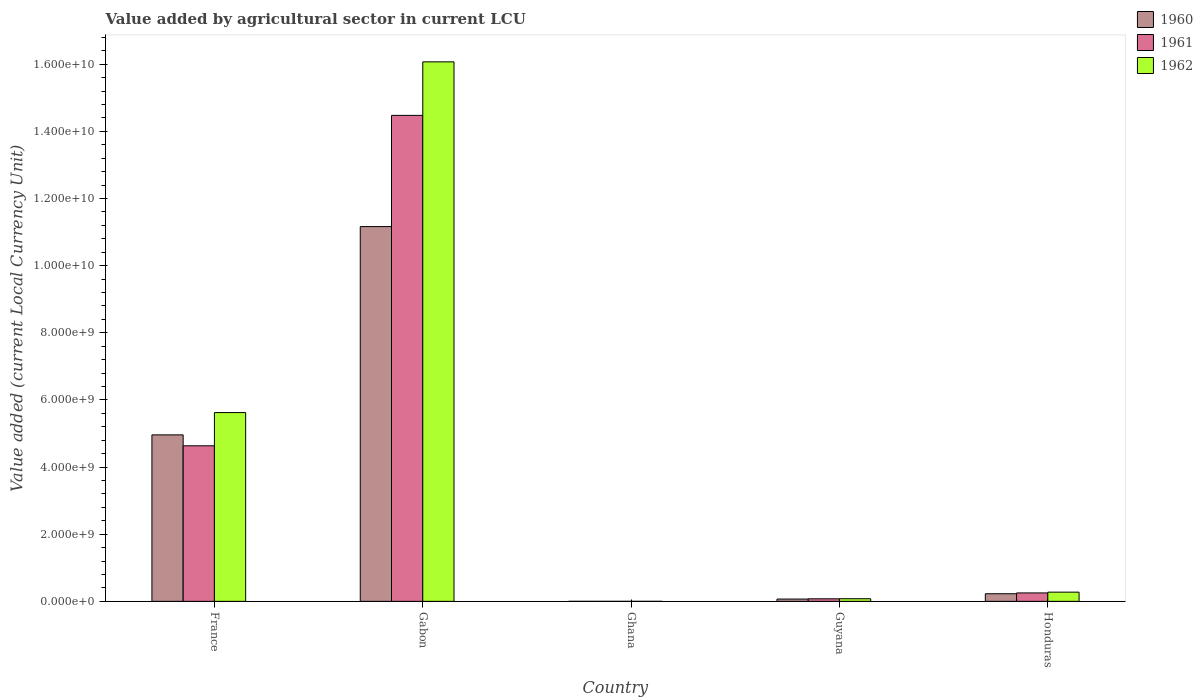How many different coloured bars are there?
Your answer should be very brief. 3. How many groups of bars are there?
Keep it short and to the point. 5. Are the number of bars per tick equal to the number of legend labels?
Your answer should be compact. Yes. Are the number of bars on each tick of the X-axis equal?
Ensure brevity in your answer.  Yes. How many bars are there on the 1st tick from the left?
Your answer should be compact. 3. How many bars are there on the 3rd tick from the right?
Make the answer very short. 3. What is the label of the 3rd group of bars from the left?
Offer a very short reply. Ghana. What is the value added by agricultural sector in 1960 in Gabon?
Your answer should be compact. 1.12e+1. Across all countries, what is the maximum value added by agricultural sector in 1961?
Provide a short and direct response. 1.45e+1. Across all countries, what is the minimum value added by agricultural sector in 1962?
Your response must be concise. 3.74e+04. In which country was the value added by agricultural sector in 1962 maximum?
Your answer should be very brief. Gabon. In which country was the value added by agricultural sector in 1961 minimum?
Provide a short and direct response. Ghana. What is the total value added by agricultural sector in 1961 in the graph?
Your answer should be compact. 1.94e+1. What is the difference between the value added by agricultural sector in 1962 in Ghana and that in Guyana?
Your response must be concise. -7.84e+07. What is the difference between the value added by agricultural sector in 1961 in France and the value added by agricultural sector in 1962 in Honduras?
Provide a short and direct response. 4.36e+09. What is the average value added by agricultural sector in 1961 per country?
Provide a short and direct response. 3.89e+09. What is the difference between the value added by agricultural sector of/in 1961 and value added by agricultural sector of/in 1960 in Guyana?
Make the answer very short. 7.20e+06. What is the ratio of the value added by agricultural sector in 1960 in Gabon to that in Honduras?
Make the answer very short. 49.18. Is the difference between the value added by agricultural sector in 1961 in Ghana and Honduras greater than the difference between the value added by agricultural sector in 1960 in Ghana and Honduras?
Your answer should be compact. No. What is the difference between the highest and the second highest value added by agricultural sector in 1961?
Make the answer very short. 1.42e+1. What is the difference between the highest and the lowest value added by agricultural sector in 1960?
Your response must be concise. 1.12e+1. In how many countries, is the value added by agricultural sector in 1962 greater than the average value added by agricultural sector in 1962 taken over all countries?
Your answer should be compact. 2. Is the sum of the value added by agricultural sector in 1960 in Gabon and Guyana greater than the maximum value added by agricultural sector in 1961 across all countries?
Keep it short and to the point. No. What does the 3rd bar from the right in France represents?
Offer a terse response. 1960. Is it the case that in every country, the sum of the value added by agricultural sector in 1960 and value added by agricultural sector in 1962 is greater than the value added by agricultural sector in 1961?
Offer a terse response. Yes. How many bars are there?
Provide a short and direct response. 15. Are all the bars in the graph horizontal?
Your answer should be very brief. No. What is the difference between two consecutive major ticks on the Y-axis?
Your answer should be compact. 2.00e+09. Does the graph contain any zero values?
Keep it short and to the point. No. Does the graph contain grids?
Your answer should be very brief. No. How are the legend labels stacked?
Keep it short and to the point. Vertical. What is the title of the graph?
Your answer should be very brief. Value added by agricultural sector in current LCU. What is the label or title of the Y-axis?
Your response must be concise. Value added (current Local Currency Unit). What is the Value added (current Local Currency Unit) of 1960 in France?
Give a very brief answer. 4.96e+09. What is the Value added (current Local Currency Unit) in 1961 in France?
Your answer should be compact. 4.63e+09. What is the Value added (current Local Currency Unit) in 1962 in France?
Offer a very short reply. 5.62e+09. What is the Value added (current Local Currency Unit) in 1960 in Gabon?
Keep it short and to the point. 1.12e+1. What is the Value added (current Local Currency Unit) of 1961 in Gabon?
Make the answer very short. 1.45e+1. What is the Value added (current Local Currency Unit) in 1962 in Gabon?
Provide a short and direct response. 1.61e+1. What is the Value added (current Local Currency Unit) in 1960 in Ghana?
Ensure brevity in your answer.  3.55e+04. What is the Value added (current Local Currency Unit) of 1961 in Ghana?
Ensure brevity in your answer.  3.29e+04. What is the Value added (current Local Currency Unit) of 1962 in Ghana?
Your answer should be compact. 3.74e+04. What is the Value added (current Local Currency Unit) of 1960 in Guyana?
Your answer should be very brief. 6.88e+07. What is the Value added (current Local Currency Unit) in 1961 in Guyana?
Your answer should be very brief. 7.60e+07. What is the Value added (current Local Currency Unit) of 1962 in Guyana?
Give a very brief answer. 7.84e+07. What is the Value added (current Local Currency Unit) in 1960 in Honduras?
Provide a succinct answer. 2.27e+08. What is the Value added (current Local Currency Unit) in 1961 in Honduras?
Your response must be concise. 2.51e+08. What is the Value added (current Local Currency Unit) in 1962 in Honduras?
Ensure brevity in your answer.  2.74e+08. Across all countries, what is the maximum Value added (current Local Currency Unit) of 1960?
Your answer should be very brief. 1.12e+1. Across all countries, what is the maximum Value added (current Local Currency Unit) in 1961?
Ensure brevity in your answer.  1.45e+1. Across all countries, what is the maximum Value added (current Local Currency Unit) in 1962?
Give a very brief answer. 1.61e+1. Across all countries, what is the minimum Value added (current Local Currency Unit) in 1960?
Offer a very short reply. 3.55e+04. Across all countries, what is the minimum Value added (current Local Currency Unit) in 1961?
Give a very brief answer. 3.29e+04. Across all countries, what is the minimum Value added (current Local Currency Unit) of 1962?
Give a very brief answer. 3.74e+04. What is the total Value added (current Local Currency Unit) of 1960 in the graph?
Make the answer very short. 1.64e+1. What is the total Value added (current Local Currency Unit) in 1961 in the graph?
Provide a short and direct response. 1.94e+1. What is the total Value added (current Local Currency Unit) in 1962 in the graph?
Your response must be concise. 2.20e+1. What is the difference between the Value added (current Local Currency Unit) in 1960 in France and that in Gabon?
Offer a very short reply. -6.20e+09. What is the difference between the Value added (current Local Currency Unit) in 1961 in France and that in Gabon?
Your answer should be very brief. -9.84e+09. What is the difference between the Value added (current Local Currency Unit) of 1962 in France and that in Gabon?
Provide a succinct answer. -1.04e+1. What is the difference between the Value added (current Local Currency Unit) of 1960 in France and that in Ghana?
Your answer should be very brief. 4.96e+09. What is the difference between the Value added (current Local Currency Unit) in 1961 in France and that in Ghana?
Offer a terse response. 4.63e+09. What is the difference between the Value added (current Local Currency Unit) in 1962 in France and that in Ghana?
Ensure brevity in your answer.  5.62e+09. What is the difference between the Value added (current Local Currency Unit) of 1960 in France and that in Guyana?
Provide a succinct answer. 4.89e+09. What is the difference between the Value added (current Local Currency Unit) in 1961 in France and that in Guyana?
Ensure brevity in your answer.  4.56e+09. What is the difference between the Value added (current Local Currency Unit) in 1962 in France and that in Guyana?
Make the answer very short. 5.55e+09. What is the difference between the Value added (current Local Currency Unit) in 1960 in France and that in Honduras?
Your answer should be very brief. 4.73e+09. What is the difference between the Value added (current Local Currency Unit) in 1961 in France and that in Honduras?
Provide a succinct answer. 4.38e+09. What is the difference between the Value added (current Local Currency Unit) of 1962 in France and that in Honduras?
Offer a terse response. 5.35e+09. What is the difference between the Value added (current Local Currency Unit) in 1960 in Gabon and that in Ghana?
Your answer should be very brief. 1.12e+1. What is the difference between the Value added (current Local Currency Unit) in 1961 in Gabon and that in Ghana?
Give a very brief answer. 1.45e+1. What is the difference between the Value added (current Local Currency Unit) of 1962 in Gabon and that in Ghana?
Keep it short and to the point. 1.61e+1. What is the difference between the Value added (current Local Currency Unit) of 1960 in Gabon and that in Guyana?
Ensure brevity in your answer.  1.11e+1. What is the difference between the Value added (current Local Currency Unit) of 1961 in Gabon and that in Guyana?
Provide a succinct answer. 1.44e+1. What is the difference between the Value added (current Local Currency Unit) in 1962 in Gabon and that in Guyana?
Your answer should be compact. 1.60e+1. What is the difference between the Value added (current Local Currency Unit) of 1960 in Gabon and that in Honduras?
Offer a very short reply. 1.09e+1. What is the difference between the Value added (current Local Currency Unit) in 1961 in Gabon and that in Honduras?
Your answer should be compact. 1.42e+1. What is the difference between the Value added (current Local Currency Unit) in 1962 in Gabon and that in Honduras?
Give a very brief answer. 1.58e+1. What is the difference between the Value added (current Local Currency Unit) of 1960 in Ghana and that in Guyana?
Ensure brevity in your answer.  -6.88e+07. What is the difference between the Value added (current Local Currency Unit) of 1961 in Ghana and that in Guyana?
Offer a very short reply. -7.60e+07. What is the difference between the Value added (current Local Currency Unit) of 1962 in Ghana and that in Guyana?
Your answer should be compact. -7.84e+07. What is the difference between the Value added (current Local Currency Unit) of 1960 in Ghana and that in Honduras?
Give a very brief answer. -2.27e+08. What is the difference between the Value added (current Local Currency Unit) of 1961 in Ghana and that in Honduras?
Provide a succinct answer. -2.51e+08. What is the difference between the Value added (current Local Currency Unit) in 1962 in Ghana and that in Honduras?
Your answer should be compact. -2.74e+08. What is the difference between the Value added (current Local Currency Unit) in 1960 in Guyana and that in Honduras?
Offer a very short reply. -1.58e+08. What is the difference between the Value added (current Local Currency Unit) in 1961 in Guyana and that in Honduras?
Ensure brevity in your answer.  -1.75e+08. What is the difference between the Value added (current Local Currency Unit) in 1962 in Guyana and that in Honduras?
Provide a short and direct response. -1.96e+08. What is the difference between the Value added (current Local Currency Unit) of 1960 in France and the Value added (current Local Currency Unit) of 1961 in Gabon?
Keep it short and to the point. -9.52e+09. What is the difference between the Value added (current Local Currency Unit) in 1960 in France and the Value added (current Local Currency Unit) in 1962 in Gabon?
Keep it short and to the point. -1.11e+1. What is the difference between the Value added (current Local Currency Unit) of 1961 in France and the Value added (current Local Currency Unit) of 1962 in Gabon?
Offer a very short reply. -1.14e+1. What is the difference between the Value added (current Local Currency Unit) in 1960 in France and the Value added (current Local Currency Unit) in 1961 in Ghana?
Your response must be concise. 4.96e+09. What is the difference between the Value added (current Local Currency Unit) in 1960 in France and the Value added (current Local Currency Unit) in 1962 in Ghana?
Make the answer very short. 4.96e+09. What is the difference between the Value added (current Local Currency Unit) in 1961 in France and the Value added (current Local Currency Unit) in 1962 in Ghana?
Offer a terse response. 4.63e+09. What is the difference between the Value added (current Local Currency Unit) of 1960 in France and the Value added (current Local Currency Unit) of 1961 in Guyana?
Provide a succinct answer. 4.88e+09. What is the difference between the Value added (current Local Currency Unit) of 1960 in France and the Value added (current Local Currency Unit) of 1962 in Guyana?
Your answer should be very brief. 4.88e+09. What is the difference between the Value added (current Local Currency Unit) of 1961 in France and the Value added (current Local Currency Unit) of 1962 in Guyana?
Make the answer very short. 4.56e+09. What is the difference between the Value added (current Local Currency Unit) in 1960 in France and the Value added (current Local Currency Unit) in 1961 in Honduras?
Your response must be concise. 4.71e+09. What is the difference between the Value added (current Local Currency Unit) in 1960 in France and the Value added (current Local Currency Unit) in 1962 in Honduras?
Offer a terse response. 4.69e+09. What is the difference between the Value added (current Local Currency Unit) of 1961 in France and the Value added (current Local Currency Unit) of 1962 in Honduras?
Your response must be concise. 4.36e+09. What is the difference between the Value added (current Local Currency Unit) in 1960 in Gabon and the Value added (current Local Currency Unit) in 1961 in Ghana?
Provide a short and direct response. 1.12e+1. What is the difference between the Value added (current Local Currency Unit) of 1960 in Gabon and the Value added (current Local Currency Unit) of 1962 in Ghana?
Your answer should be very brief. 1.12e+1. What is the difference between the Value added (current Local Currency Unit) in 1961 in Gabon and the Value added (current Local Currency Unit) in 1962 in Ghana?
Keep it short and to the point. 1.45e+1. What is the difference between the Value added (current Local Currency Unit) in 1960 in Gabon and the Value added (current Local Currency Unit) in 1961 in Guyana?
Your response must be concise. 1.11e+1. What is the difference between the Value added (current Local Currency Unit) in 1960 in Gabon and the Value added (current Local Currency Unit) in 1962 in Guyana?
Offer a terse response. 1.11e+1. What is the difference between the Value added (current Local Currency Unit) of 1961 in Gabon and the Value added (current Local Currency Unit) of 1962 in Guyana?
Ensure brevity in your answer.  1.44e+1. What is the difference between the Value added (current Local Currency Unit) in 1960 in Gabon and the Value added (current Local Currency Unit) in 1961 in Honduras?
Make the answer very short. 1.09e+1. What is the difference between the Value added (current Local Currency Unit) in 1960 in Gabon and the Value added (current Local Currency Unit) in 1962 in Honduras?
Give a very brief answer. 1.09e+1. What is the difference between the Value added (current Local Currency Unit) of 1961 in Gabon and the Value added (current Local Currency Unit) of 1962 in Honduras?
Make the answer very short. 1.42e+1. What is the difference between the Value added (current Local Currency Unit) in 1960 in Ghana and the Value added (current Local Currency Unit) in 1961 in Guyana?
Ensure brevity in your answer.  -7.60e+07. What is the difference between the Value added (current Local Currency Unit) of 1960 in Ghana and the Value added (current Local Currency Unit) of 1962 in Guyana?
Offer a terse response. -7.84e+07. What is the difference between the Value added (current Local Currency Unit) of 1961 in Ghana and the Value added (current Local Currency Unit) of 1962 in Guyana?
Ensure brevity in your answer.  -7.84e+07. What is the difference between the Value added (current Local Currency Unit) in 1960 in Ghana and the Value added (current Local Currency Unit) in 1961 in Honduras?
Your response must be concise. -2.51e+08. What is the difference between the Value added (current Local Currency Unit) of 1960 in Ghana and the Value added (current Local Currency Unit) of 1962 in Honduras?
Provide a succinct answer. -2.74e+08. What is the difference between the Value added (current Local Currency Unit) of 1961 in Ghana and the Value added (current Local Currency Unit) of 1962 in Honduras?
Your answer should be very brief. -2.74e+08. What is the difference between the Value added (current Local Currency Unit) of 1960 in Guyana and the Value added (current Local Currency Unit) of 1961 in Honduras?
Ensure brevity in your answer.  -1.82e+08. What is the difference between the Value added (current Local Currency Unit) in 1960 in Guyana and the Value added (current Local Currency Unit) in 1962 in Honduras?
Your response must be concise. -2.06e+08. What is the difference between the Value added (current Local Currency Unit) in 1961 in Guyana and the Value added (current Local Currency Unit) in 1962 in Honduras?
Make the answer very short. -1.98e+08. What is the average Value added (current Local Currency Unit) of 1960 per country?
Ensure brevity in your answer.  3.28e+09. What is the average Value added (current Local Currency Unit) in 1961 per country?
Provide a short and direct response. 3.89e+09. What is the average Value added (current Local Currency Unit) of 1962 per country?
Provide a succinct answer. 4.41e+09. What is the difference between the Value added (current Local Currency Unit) in 1960 and Value added (current Local Currency Unit) in 1961 in France?
Offer a very short reply. 3.26e+08. What is the difference between the Value added (current Local Currency Unit) of 1960 and Value added (current Local Currency Unit) of 1962 in France?
Offer a terse response. -6.64e+08. What is the difference between the Value added (current Local Currency Unit) in 1961 and Value added (current Local Currency Unit) in 1962 in France?
Make the answer very short. -9.90e+08. What is the difference between the Value added (current Local Currency Unit) of 1960 and Value added (current Local Currency Unit) of 1961 in Gabon?
Your answer should be very brief. -3.31e+09. What is the difference between the Value added (current Local Currency Unit) of 1960 and Value added (current Local Currency Unit) of 1962 in Gabon?
Your answer should be very brief. -4.91e+09. What is the difference between the Value added (current Local Currency Unit) of 1961 and Value added (current Local Currency Unit) of 1962 in Gabon?
Give a very brief answer. -1.59e+09. What is the difference between the Value added (current Local Currency Unit) of 1960 and Value added (current Local Currency Unit) of 1961 in Ghana?
Provide a short and direct response. 2600. What is the difference between the Value added (current Local Currency Unit) in 1960 and Value added (current Local Currency Unit) in 1962 in Ghana?
Provide a short and direct response. -1900. What is the difference between the Value added (current Local Currency Unit) in 1961 and Value added (current Local Currency Unit) in 1962 in Ghana?
Your response must be concise. -4500. What is the difference between the Value added (current Local Currency Unit) in 1960 and Value added (current Local Currency Unit) in 1961 in Guyana?
Provide a short and direct response. -7.20e+06. What is the difference between the Value added (current Local Currency Unit) in 1960 and Value added (current Local Currency Unit) in 1962 in Guyana?
Give a very brief answer. -9.60e+06. What is the difference between the Value added (current Local Currency Unit) in 1961 and Value added (current Local Currency Unit) in 1962 in Guyana?
Your response must be concise. -2.40e+06. What is the difference between the Value added (current Local Currency Unit) in 1960 and Value added (current Local Currency Unit) in 1961 in Honduras?
Provide a short and direct response. -2.42e+07. What is the difference between the Value added (current Local Currency Unit) in 1960 and Value added (current Local Currency Unit) in 1962 in Honduras?
Provide a short and direct response. -4.75e+07. What is the difference between the Value added (current Local Currency Unit) in 1961 and Value added (current Local Currency Unit) in 1962 in Honduras?
Your answer should be very brief. -2.33e+07. What is the ratio of the Value added (current Local Currency Unit) in 1960 in France to that in Gabon?
Your response must be concise. 0.44. What is the ratio of the Value added (current Local Currency Unit) of 1961 in France to that in Gabon?
Give a very brief answer. 0.32. What is the ratio of the Value added (current Local Currency Unit) in 1962 in France to that in Gabon?
Keep it short and to the point. 0.35. What is the ratio of the Value added (current Local Currency Unit) in 1960 in France to that in Ghana?
Give a very brief answer. 1.40e+05. What is the ratio of the Value added (current Local Currency Unit) in 1961 in France to that in Ghana?
Ensure brevity in your answer.  1.41e+05. What is the ratio of the Value added (current Local Currency Unit) of 1962 in France to that in Ghana?
Your answer should be very brief. 1.50e+05. What is the ratio of the Value added (current Local Currency Unit) in 1960 in France to that in Guyana?
Your answer should be compact. 72.09. What is the ratio of the Value added (current Local Currency Unit) of 1961 in France to that in Guyana?
Your response must be concise. 60.97. What is the ratio of the Value added (current Local Currency Unit) in 1962 in France to that in Guyana?
Your answer should be very brief. 71.73. What is the ratio of the Value added (current Local Currency Unit) in 1960 in France to that in Honduras?
Your answer should be very brief. 21.85. What is the ratio of the Value added (current Local Currency Unit) of 1961 in France to that in Honduras?
Provide a short and direct response. 18.45. What is the ratio of the Value added (current Local Currency Unit) in 1962 in France to that in Honduras?
Your response must be concise. 20.49. What is the ratio of the Value added (current Local Currency Unit) of 1960 in Gabon to that in Ghana?
Provide a short and direct response. 3.14e+05. What is the ratio of the Value added (current Local Currency Unit) of 1961 in Gabon to that in Ghana?
Ensure brevity in your answer.  4.40e+05. What is the ratio of the Value added (current Local Currency Unit) of 1962 in Gabon to that in Ghana?
Provide a succinct answer. 4.30e+05. What is the ratio of the Value added (current Local Currency Unit) in 1960 in Gabon to that in Guyana?
Make the answer very short. 162.28. What is the ratio of the Value added (current Local Currency Unit) of 1961 in Gabon to that in Guyana?
Your response must be concise. 190.49. What is the ratio of the Value added (current Local Currency Unit) of 1962 in Gabon to that in Guyana?
Ensure brevity in your answer.  205. What is the ratio of the Value added (current Local Currency Unit) in 1960 in Gabon to that in Honduras?
Provide a short and direct response. 49.18. What is the ratio of the Value added (current Local Currency Unit) in 1961 in Gabon to that in Honduras?
Make the answer very short. 57.63. What is the ratio of the Value added (current Local Currency Unit) in 1962 in Gabon to that in Honduras?
Offer a terse response. 58.55. What is the ratio of the Value added (current Local Currency Unit) in 1960 in Ghana to that in Guyana?
Ensure brevity in your answer.  0. What is the ratio of the Value added (current Local Currency Unit) of 1962 in Ghana to that in Guyana?
Ensure brevity in your answer.  0. What is the ratio of the Value added (current Local Currency Unit) in 1961 in Ghana to that in Honduras?
Provide a short and direct response. 0. What is the ratio of the Value added (current Local Currency Unit) of 1960 in Guyana to that in Honduras?
Your response must be concise. 0.3. What is the ratio of the Value added (current Local Currency Unit) in 1961 in Guyana to that in Honduras?
Provide a short and direct response. 0.3. What is the ratio of the Value added (current Local Currency Unit) in 1962 in Guyana to that in Honduras?
Offer a very short reply. 0.29. What is the difference between the highest and the second highest Value added (current Local Currency Unit) in 1960?
Provide a short and direct response. 6.20e+09. What is the difference between the highest and the second highest Value added (current Local Currency Unit) in 1961?
Provide a succinct answer. 9.84e+09. What is the difference between the highest and the second highest Value added (current Local Currency Unit) of 1962?
Provide a short and direct response. 1.04e+1. What is the difference between the highest and the lowest Value added (current Local Currency Unit) in 1960?
Provide a short and direct response. 1.12e+1. What is the difference between the highest and the lowest Value added (current Local Currency Unit) of 1961?
Make the answer very short. 1.45e+1. What is the difference between the highest and the lowest Value added (current Local Currency Unit) in 1962?
Your answer should be very brief. 1.61e+1. 